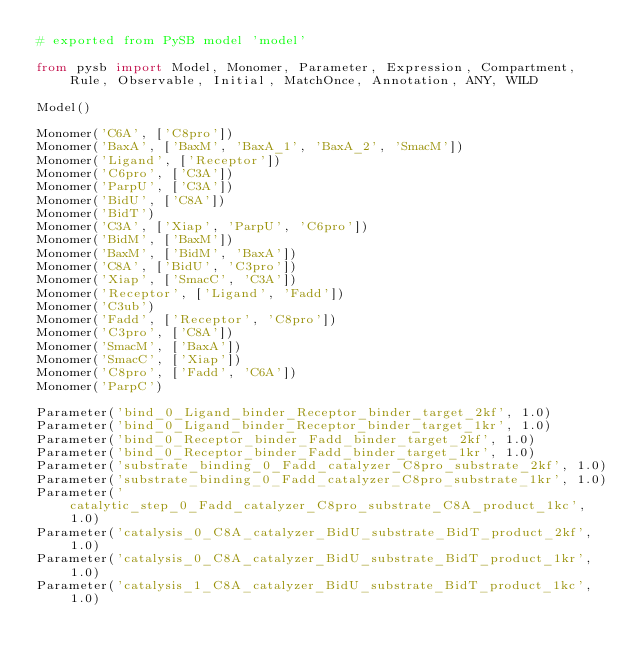<code> <loc_0><loc_0><loc_500><loc_500><_Python_># exported from PySB model 'model'

from pysb import Model, Monomer, Parameter, Expression, Compartment, Rule, Observable, Initial, MatchOnce, Annotation, ANY, WILD

Model()

Monomer('C6A', ['C8pro'])
Monomer('BaxA', ['BaxM', 'BaxA_1', 'BaxA_2', 'SmacM'])
Monomer('Ligand', ['Receptor'])
Monomer('C6pro', ['C3A'])
Monomer('ParpU', ['C3A'])
Monomer('BidU', ['C8A'])
Monomer('BidT')
Monomer('C3A', ['Xiap', 'ParpU', 'C6pro'])
Monomer('BidM', ['BaxM'])
Monomer('BaxM', ['BidM', 'BaxA'])
Monomer('C8A', ['BidU', 'C3pro'])
Monomer('Xiap', ['SmacC', 'C3A'])
Monomer('Receptor', ['Ligand', 'Fadd'])
Monomer('C3ub')
Monomer('Fadd', ['Receptor', 'C8pro'])
Monomer('C3pro', ['C8A'])
Monomer('SmacM', ['BaxA'])
Monomer('SmacC', ['Xiap'])
Monomer('C8pro', ['Fadd', 'C6A'])
Monomer('ParpC')

Parameter('bind_0_Ligand_binder_Receptor_binder_target_2kf', 1.0)
Parameter('bind_0_Ligand_binder_Receptor_binder_target_1kr', 1.0)
Parameter('bind_0_Receptor_binder_Fadd_binder_target_2kf', 1.0)
Parameter('bind_0_Receptor_binder_Fadd_binder_target_1kr', 1.0)
Parameter('substrate_binding_0_Fadd_catalyzer_C8pro_substrate_2kf', 1.0)
Parameter('substrate_binding_0_Fadd_catalyzer_C8pro_substrate_1kr', 1.0)
Parameter('catalytic_step_0_Fadd_catalyzer_C8pro_substrate_C8A_product_1kc', 1.0)
Parameter('catalysis_0_C8A_catalyzer_BidU_substrate_BidT_product_2kf', 1.0)
Parameter('catalysis_0_C8A_catalyzer_BidU_substrate_BidT_product_1kr', 1.0)
Parameter('catalysis_1_C8A_catalyzer_BidU_substrate_BidT_product_1kc', 1.0)</code> 